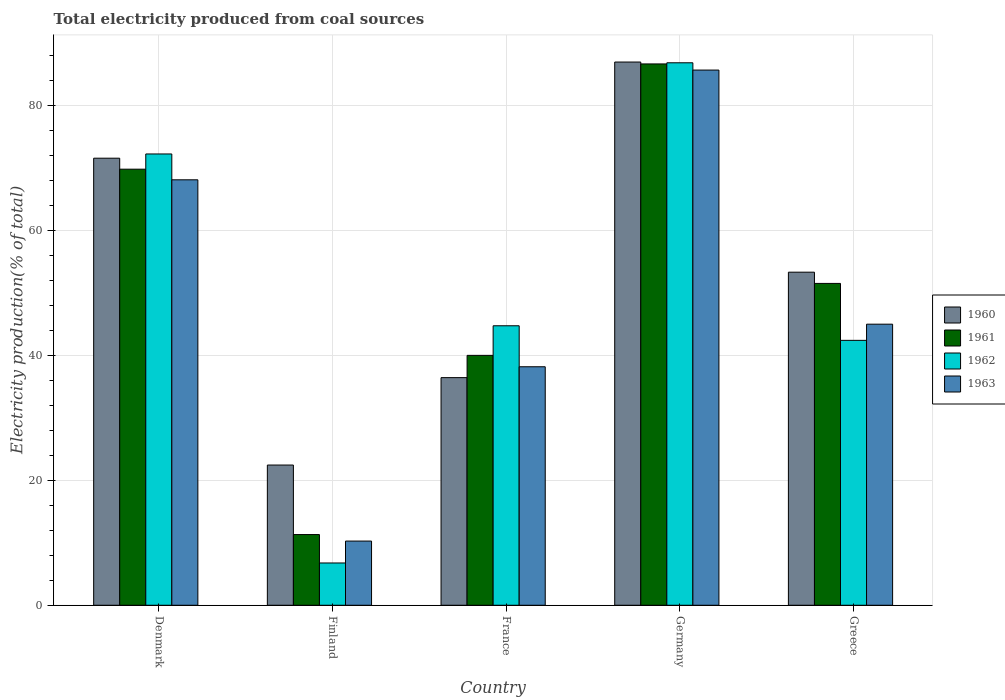How many groups of bars are there?
Offer a terse response. 5. What is the label of the 5th group of bars from the left?
Ensure brevity in your answer.  Greece. What is the total electricity produced in 1963 in Greece?
Offer a very short reply. 45.03. Across all countries, what is the maximum total electricity produced in 1961?
Make the answer very short. 86.73. Across all countries, what is the minimum total electricity produced in 1961?
Your answer should be very brief. 11.33. In which country was the total electricity produced in 1962 maximum?
Provide a short and direct response. Germany. In which country was the total electricity produced in 1962 minimum?
Your answer should be compact. Finland. What is the total total electricity produced in 1961 in the graph?
Make the answer very short. 259.52. What is the difference between the total electricity produced in 1960 in France and that in Germany?
Provide a succinct answer. -50.56. What is the difference between the total electricity produced in 1961 in Greece and the total electricity produced in 1962 in Germany?
Give a very brief answer. -35.35. What is the average total electricity produced in 1962 per country?
Your answer should be compact. 50.64. What is the difference between the total electricity produced of/in 1963 and total electricity produced of/in 1960 in Denmark?
Offer a very short reply. -3.46. What is the ratio of the total electricity produced in 1963 in Denmark to that in Greece?
Make the answer very short. 1.51. Is the total electricity produced in 1963 in Denmark less than that in Finland?
Your answer should be very brief. No. Is the difference between the total electricity produced in 1963 in Finland and Germany greater than the difference between the total electricity produced in 1960 in Finland and Germany?
Offer a very short reply. No. What is the difference between the highest and the second highest total electricity produced in 1962?
Offer a very short reply. 27.52. What is the difference between the highest and the lowest total electricity produced in 1961?
Ensure brevity in your answer.  75.4. In how many countries, is the total electricity produced in 1962 greater than the average total electricity produced in 1962 taken over all countries?
Ensure brevity in your answer.  2. Is it the case that in every country, the sum of the total electricity produced in 1962 and total electricity produced in 1963 is greater than the sum of total electricity produced in 1960 and total electricity produced in 1961?
Offer a terse response. No. What does the 3rd bar from the right in France represents?
Your answer should be very brief. 1961. Is it the case that in every country, the sum of the total electricity produced in 1960 and total electricity produced in 1962 is greater than the total electricity produced in 1963?
Ensure brevity in your answer.  Yes. What is the difference between two consecutive major ticks on the Y-axis?
Offer a very short reply. 20. Are the values on the major ticks of Y-axis written in scientific E-notation?
Your answer should be very brief. No. Does the graph contain grids?
Provide a succinct answer. Yes. Where does the legend appear in the graph?
Provide a short and direct response. Center right. How are the legend labels stacked?
Offer a very short reply. Vertical. What is the title of the graph?
Provide a succinct answer. Total electricity produced from coal sources. Does "1977" appear as one of the legend labels in the graph?
Make the answer very short. No. What is the Electricity production(% of total) of 1960 in Denmark?
Your answer should be compact. 71.62. What is the Electricity production(% of total) in 1961 in Denmark?
Keep it short and to the point. 69.86. What is the Electricity production(% of total) in 1962 in Denmark?
Ensure brevity in your answer.  72.3. What is the Electricity production(% of total) in 1963 in Denmark?
Make the answer very short. 68.16. What is the Electricity production(% of total) in 1960 in Finland?
Provide a short and direct response. 22.46. What is the Electricity production(% of total) of 1961 in Finland?
Your response must be concise. 11.33. What is the Electricity production(% of total) of 1962 in Finland?
Your answer should be very brief. 6.78. What is the Electricity production(% of total) in 1963 in Finland?
Offer a terse response. 10.28. What is the Electricity production(% of total) of 1960 in France?
Offer a terse response. 36.47. What is the Electricity production(% of total) in 1961 in France?
Give a very brief answer. 40.03. What is the Electricity production(% of total) in 1962 in France?
Keep it short and to the point. 44.78. What is the Electricity production(% of total) of 1963 in France?
Make the answer very short. 38.21. What is the Electricity production(% of total) of 1960 in Germany?
Offer a very short reply. 87.03. What is the Electricity production(% of total) in 1961 in Germany?
Your response must be concise. 86.73. What is the Electricity production(% of total) of 1962 in Germany?
Make the answer very short. 86.91. What is the Electricity production(% of total) of 1963 in Germany?
Provide a short and direct response. 85.74. What is the Electricity production(% of total) of 1960 in Greece?
Your answer should be compact. 53.36. What is the Electricity production(% of total) of 1961 in Greece?
Ensure brevity in your answer.  51.56. What is the Electricity production(% of total) in 1962 in Greece?
Provide a succinct answer. 42.44. What is the Electricity production(% of total) of 1963 in Greece?
Provide a short and direct response. 45.03. Across all countries, what is the maximum Electricity production(% of total) in 1960?
Your answer should be compact. 87.03. Across all countries, what is the maximum Electricity production(% of total) in 1961?
Ensure brevity in your answer.  86.73. Across all countries, what is the maximum Electricity production(% of total) of 1962?
Your response must be concise. 86.91. Across all countries, what is the maximum Electricity production(% of total) of 1963?
Your answer should be very brief. 85.74. Across all countries, what is the minimum Electricity production(% of total) in 1960?
Keep it short and to the point. 22.46. Across all countries, what is the minimum Electricity production(% of total) of 1961?
Keep it short and to the point. 11.33. Across all countries, what is the minimum Electricity production(% of total) in 1962?
Keep it short and to the point. 6.78. Across all countries, what is the minimum Electricity production(% of total) in 1963?
Give a very brief answer. 10.28. What is the total Electricity production(% of total) in 1960 in the graph?
Provide a succinct answer. 270.95. What is the total Electricity production(% of total) of 1961 in the graph?
Your response must be concise. 259.52. What is the total Electricity production(% of total) of 1962 in the graph?
Provide a short and direct response. 253.2. What is the total Electricity production(% of total) in 1963 in the graph?
Your answer should be compact. 247.43. What is the difference between the Electricity production(% of total) of 1960 in Denmark and that in Finland?
Make the answer very short. 49.16. What is the difference between the Electricity production(% of total) of 1961 in Denmark and that in Finland?
Offer a very short reply. 58.54. What is the difference between the Electricity production(% of total) of 1962 in Denmark and that in Finland?
Make the answer very short. 65.53. What is the difference between the Electricity production(% of total) in 1963 in Denmark and that in Finland?
Ensure brevity in your answer.  57.88. What is the difference between the Electricity production(% of total) of 1960 in Denmark and that in France?
Ensure brevity in your answer.  35.16. What is the difference between the Electricity production(% of total) of 1961 in Denmark and that in France?
Keep it short and to the point. 29.83. What is the difference between the Electricity production(% of total) of 1962 in Denmark and that in France?
Ensure brevity in your answer.  27.52. What is the difference between the Electricity production(% of total) of 1963 in Denmark and that in France?
Make the answer very short. 29.95. What is the difference between the Electricity production(% of total) of 1960 in Denmark and that in Germany?
Your answer should be very brief. -15.4. What is the difference between the Electricity production(% of total) in 1961 in Denmark and that in Germany?
Give a very brief answer. -16.86. What is the difference between the Electricity production(% of total) of 1962 in Denmark and that in Germany?
Your response must be concise. -14.61. What is the difference between the Electricity production(% of total) of 1963 in Denmark and that in Germany?
Offer a very short reply. -17.58. What is the difference between the Electricity production(% of total) in 1960 in Denmark and that in Greece?
Make the answer very short. 18.26. What is the difference between the Electricity production(% of total) in 1961 in Denmark and that in Greece?
Provide a succinct answer. 18.3. What is the difference between the Electricity production(% of total) in 1962 in Denmark and that in Greece?
Offer a very short reply. 29.86. What is the difference between the Electricity production(% of total) of 1963 in Denmark and that in Greece?
Your answer should be compact. 23.13. What is the difference between the Electricity production(% of total) of 1960 in Finland and that in France?
Your answer should be compact. -14.01. What is the difference between the Electricity production(% of total) in 1961 in Finland and that in France?
Give a very brief answer. -28.71. What is the difference between the Electricity production(% of total) in 1962 in Finland and that in France?
Your answer should be compact. -38. What is the difference between the Electricity production(% of total) in 1963 in Finland and that in France?
Your answer should be compact. -27.93. What is the difference between the Electricity production(% of total) in 1960 in Finland and that in Germany?
Offer a very short reply. -64.57. What is the difference between the Electricity production(% of total) of 1961 in Finland and that in Germany?
Provide a succinct answer. -75.4. What is the difference between the Electricity production(% of total) in 1962 in Finland and that in Germany?
Provide a short and direct response. -80.13. What is the difference between the Electricity production(% of total) of 1963 in Finland and that in Germany?
Provide a short and direct response. -75.46. What is the difference between the Electricity production(% of total) in 1960 in Finland and that in Greece?
Provide a short and direct response. -30.9. What is the difference between the Electricity production(% of total) in 1961 in Finland and that in Greece?
Provide a short and direct response. -40.24. What is the difference between the Electricity production(% of total) of 1962 in Finland and that in Greece?
Your answer should be compact. -35.66. What is the difference between the Electricity production(% of total) of 1963 in Finland and that in Greece?
Your answer should be very brief. -34.75. What is the difference between the Electricity production(% of total) in 1960 in France and that in Germany?
Offer a very short reply. -50.56. What is the difference between the Electricity production(% of total) of 1961 in France and that in Germany?
Keep it short and to the point. -46.69. What is the difference between the Electricity production(% of total) in 1962 in France and that in Germany?
Your response must be concise. -42.13. What is the difference between the Electricity production(% of total) of 1963 in France and that in Germany?
Provide a short and direct response. -47.53. What is the difference between the Electricity production(% of total) of 1960 in France and that in Greece?
Your response must be concise. -16.89. What is the difference between the Electricity production(% of total) in 1961 in France and that in Greece?
Provide a short and direct response. -11.53. What is the difference between the Electricity production(% of total) of 1962 in France and that in Greece?
Offer a very short reply. 2.34. What is the difference between the Electricity production(% of total) of 1963 in France and that in Greece?
Give a very brief answer. -6.82. What is the difference between the Electricity production(% of total) of 1960 in Germany and that in Greece?
Your answer should be very brief. 33.67. What is the difference between the Electricity production(% of total) of 1961 in Germany and that in Greece?
Ensure brevity in your answer.  35.16. What is the difference between the Electricity production(% of total) in 1962 in Germany and that in Greece?
Your answer should be compact. 44.47. What is the difference between the Electricity production(% of total) in 1963 in Germany and that in Greece?
Your answer should be compact. 40.71. What is the difference between the Electricity production(% of total) in 1960 in Denmark and the Electricity production(% of total) in 1961 in Finland?
Offer a very short reply. 60.3. What is the difference between the Electricity production(% of total) of 1960 in Denmark and the Electricity production(% of total) of 1962 in Finland?
Keep it short and to the point. 64.85. What is the difference between the Electricity production(% of total) of 1960 in Denmark and the Electricity production(% of total) of 1963 in Finland?
Provide a short and direct response. 61.34. What is the difference between the Electricity production(% of total) in 1961 in Denmark and the Electricity production(% of total) in 1962 in Finland?
Make the answer very short. 63.09. What is the difference between the Electricity production(% of total) of 1961 in Denmark and the Electricity production(% of total) of 1963 in Finland?
Your answer should be very brief. 59.58. What is the difference between the Electricity production(% of total) of 1962 in Denmark and the Electricity production(% of total) of 1963 in Finland?
Give a very brief answer. 62.02. What is the difference between the Electricity production(% of total) in 1960 in Denmark and the Electricity production(% of total) in 1961 in France?
Keep it short and to the point. 31.59. What is the difference between the Electricity production(% of total) in 1960 in Denmark and the Electricity production(% of total) in 1962 in France?
Keep it short and to the point. 26.85. What is the difference between the Electricity production(% of total) in 1960 in Denmark and the Electricity production(% of total) in 1963 in France?
Offer a very short reply. 33.41. What is the difference between the Electricity production(% of total) of 1961 in Denmark and the Electricity production(% of total) of 1962 in France?
Offer a terse response. 25.09. What is the difference between the Electricity production(% of total) in 1961 in Denmark and the Electricity production(% of total) in 1963 in France?
Ensure brevity in your answer.  31.65. What is the difference between the Electricity production(% of total) of 1962 in Denmark and the Electricity production(% of total) of 1963 in France?
Offer a terse response. 34.09. What is the difference between the Electricity production(% of total) in 1960 in Denmark and the Electricity production(% of total) in 1961 in Germany?
Ensure brevity in your answer.  -15.1. What is the difference between the Electricity production(% of total) of 1960 in Denmark and the Electricity production(% of total) of 1962 in Germany?
Your response must be concise. -15.28. What is the difference between the Electricity production(% of total) of 1960 in Denmark and the Electricity production(% of total) of 1963 in Germany?
Make the answer very short. -14.12. What is the difference between the Electricity production(% of total) in 1961 in Denmark and the Electricity production(% of total) in 1962 in Germany?
Offer a very short reply. -17.04. What is the difference between the Electricity production(% of total) in 1961 in Denmark and the Electricity production(% of total) in 1963 in Germany?
Your answer should be compact. -15.88. What is the difference between the Electricity production(% of total) in 1962 in Denmark and the Electricity production(% of total) in 1963 in Germany?
Your response must be concise. -13.44. What is the difference between the Electricity production(% of total) in 1960 in Denmark and the Electricity production(% of total) in 1961 in Greece?
Provide a short and direct response. 20.06. What is the difference between the Electricity production(% of total) of 1960 in Denmark and the Electricity production(% of total) of 1962 in Greece?
Provide a short and direct response. 29.18. What is the difference between the Electricity production(% of total) of 1960 in Denmark and the Electricity production(% of total) of 1963 in Greece?
Provide a succinct answer. 26.59. What is the difference between the Electricity production(% of total) in 1961 in Denmark and the Electricity production(% of total) in 1962 in Greece?
Give a very brief answer. 27.42. What is the difference between the Electricity production(% of total) in 1961 in Denmark and the Electricity production(% of total) in 1963 in Greece?
Your response must be concise. 24.83. What is the difference between the Electricity production(% of total) in 1962 in Denmark and the Electricity production(% of total) in 1963 in Greece?
Make the answer very short. 27.27. What is the difference between the Electricity production(% of total) in 1960 in Finland and the Electricity production(% of total) in 1961 in France?
Your answer should be compact. -17.57. What is the difference between the Electricity production(% of total) of 1960 in Finland and the Electricity production(% of total) of 1962 in France?
Make the answer very short. -22.31. What is the difference between the Electricity production(% of total) of 1960 in Finland and the Electricity production(% of total) of 1963 in France?
Provide a short and direct response. -15.75. What is the difference between the Electricity production(% of total) in 1961 in Finland and the Electricity production(% of total) in 1962 in France?
Ensure brevity in your answer.  -33.45. What is the difference between the Electricity production(% of total) in 1961 in Finland and the Electricity production(% of total) in 1963 in France?
Offer a terse response. -26.88. What is the difference between the Electricity production(% of total) in 1962 in Finland and the Electricity production(% of total) in 1963 in France?
Your answer should be very brief. -31.44. What is the difference between the Electricity production(% of total) of 1960 in Finland and the Electricity production(% of total) of 1961 in Germany?
Keep it short and to the point. -64.26. What is the difference between the Electricity production(% of total) in 1960 in Finland and the Electricity production(% of total) in 1962 in Germany?
Offer a terse response. -64.45. What is the difference between the Electricity production(% of total) in 1960 in Finland and the Electricity production(% of total) in 1963 in Germany?
Offer a very short reply. -63.28. What is the difference between the Electricity production(% of total) of 1961 in Finland and the Electricity production(% of total) of 1962 in Germany?
Your response must be concise. -75.58. What is the difference between the Electricity production(% of total) of 1961 in Finland and the Electricity production(% of total) of 1963 in Germany?
Offer a very short reply. -74.41. What is the difference between the Electricity production(% of total) in 1962 in Finland and the Electricity production(% of total) in 1963 in Germany?
Offer a terse response. -78.97. What is the difference between the Electricity production(% of total) in 1960 in Finland and the Electricity production(% of total) in 1961 in Greece?
Keep it short and to the point. -29.1. What is the difference between the Electricity production(% of total) in 1960 in Finland and the Electricity production(% of total) in 1962 in Greece?
Provide a succinct answer. -19.98. What is the difference between the Electricity production(% of total) in 1960 in Finland and the Electricity production(% of total) in 1963 in Greece?
Offer a very short reply. -22.57. What is the difference between the Electricity production(% of total) of 1961 in Finland and the Electricity production(% of total) of 1962 in Greece?
Provide a succinct answer. -31.11. What is the difference between the Electricity production(% of total) of 1961 in Finland and the Electricity production(% of total) of 1963 in Greece?
Keep it short and to the point. -33.7. What is the difference between the Electricity production(% of total) in 1962 in Finland and the Electricity production(% of total) in 1963 in Greece?
Ensure brevity in your answer.  -38.26. What is the difference between the Electricity production(% of total) of 1960 in France and the Electricity production(% of total) of 1961 in Germany?
Offer a very short reply. -50.26. What is the difference between the Electricity production(% of total) in 1960 in France and the Electricity production(% of total) in 1962 in Germany?
Offer a terse response. -50.44. What is the difference between the Electricity production(% of total) of 1960 in France and the Electricity production(% of total) of 1963 in Germany?
Provide a short and direct response. -49.27. What is the difference between the Electricity production(% of total) of 1961 in France and the Electricity production(% of total) of 1962 in Germany?
Provide a succinct answer. -46.87. What is the difference between the Electricity production(% of total) in 1961 in France and the Electricity production(% of total) in 1963 in Germany?
Give a very brief answer. -45.71. What is the difference between the Electricity production(% of total) in 1962 in France and the Electricity production(% of total) in 1963 in Germany?
Offer a terse response. -40.97. What is the difference between the Electricity production(% of total) in 1960 in France and the Electricity production(% of total) in 1961 in Greece?
Offer a very short reply. -15.09. What is the difference between the Electricity production(% of total) in 1960 in France and the Electricity production(% of total) in 1962 in Greece?
Provide a succinct answer. -5.97. What is the difference between the Electricity production(% of total) of 1960 in France and the Electricity production(% of total) of 1963 in Greece?
Keep it short and to the point. -8.56. What is the difference between the Electricity production(% of total) in 1961 in France and the Electricity production(% of total) in 1962 in Greece?
Offer a terse response. -2.41. What is the difference between the Electricity production(% of total) in 1961 in France and the Electricity production(% of total) in 1963 in Greece?
Give a very brief answer. -5. What is the difference between the Electricity production(% of total) in 1962 in France and the Electricity production(% of total) in 1963 in Greece?
Make the answer very short. -0.25. What is the difference between the Electricity production(% of total) of 1960 in Germany and the Electricity production(% of total) of 1961 in Greece?
Offer a very short reply. 35.47. What is the difference between the Electricity production(% of total) of 1960 in Germany and the Electricity production(% of total) of 1962 in Greece?
Your answer should be very brief. 44.59. What is the difference between the Electricity production(% of total) in 1960 in Germany and the Electricity production(% of total) in 1963 in Greece?
Ensure brevity in your answer.  42. What is the difference between the Electricity production(% of total) in 1961 in Germany and the Electricity production(% of total) in 1962 in Greece?
Offer a terse response. 44.29. What is the difference between the Electricity production(% of total) of 1961 in Germany and the Electricity production(% of total) of 1963 in Greece?
Offer a very short reply. 41.69. What is the difference between the Electricity production(% of total) of 1962 in Germany and the Electricity production(% of total) of 1963 in Greece?
Offer a terse response. 41.88. What is the average Electricity production(% of total) in 1960 per country?
Your answer should be compact. 54.19. What is the average Electricity production(% of total) in 1961 per country?
Provide a succinct answer. 51.9. What is the average Electricity production(% of total) in 1962 per country?
Your response must be concise. 50.64. What is the average Electricity production(% of total) of 1963 per country?
Your response must be concise. 49.49. What is the difference between the Electricity production(% of total) of 1960 and Electricity production(% of total) of 1961 in Denmark?
Your response must be concise. 1.76. What is the difference between the Electricity production(% of total) of 1960 and Electricity production(% of total) of 1962 in Denmark?
Your response must be concise. -0.68. What is the difference between the Electricity production(% of total) of 1960 and Electricity production(% of total) of 1963 in Denmark?
Your response must be concise. 3.46. What is the difference between the Electricity production(% of total) of 1961 and Electricity production(% of total) of 1962 in Denmark?
Offer a terse response. -2.44. What is the difference between the Electricity production(% of total) of 1961 and Electricity production(% of total) of 1963 in Denmark?
Give a very brief answer. 1.7. What is the difference between the Electricity production(% of total) of 1962 and Electricity production(% of total) of 1963 in Denmark?
Offer a very short reply. 4.14. What is the difference between the Electricity production(% of total) in 1960 and Electricity production(% of total) in 1961 in Finland?
Your answer should be compact. 11.14. What is the difference between the Electricity production(% of total) of 1960 and Electricity production(% of total) of 1962 in Finland?
Ensure brevity in your answer.  15.69. What is the difference between the Electricity production(% of total) of 1960 and Electricity production(% of total) of 1963 in Finland?
Offer a very short reply. 12.18. What is the difference between the Electricity production(% of total) of 1961 and Electricity production(% of total) of 1962 in Finland?
Offer a terse response. 4.55. What is the difference between the Electricity production(% of total) in 1961 and Electricity production(% of total) in 1963 in Finland?
Offer a terse response. 1.04. What is the difference between the Electricity production(% of total) of 1962 and Electricity production(% of total) of 1963 in Finland?
Provide a succinct answer. -3.51. What is the difference between the Electricity production(% of total) in 1960 and Electricity production(% of total) in 1961 in France?
Provide a succinct answer. -3.57. What is the difference between the Electricity production(% of total) of 1960 and Electricity production(% of total) of 1962 in France?
Keep it short and to the point. -8.31. What is the difference between the Electricity production(% of total) in 1960 and Electricity production(% of total) in 1963 in France?
Your answer should be compact. -1.74. What is the difference between the Electricity production(% of total) in 1961 and Electricity production(% of total) in 1962 in France?
Offer a very short reply. -4.74. What is the difference between the Electricity production(% of total) of 1961 and Electricity production(% of total) of 1963 in France?
Your answer should be compact. 1.82. What is the difference between the Electricity production(% of total) of 1962 and Electricity production(% of total) of 1963 in France?
Your answer should be very brief. 6.57. What is the difference between the Electricity production(% of total) in 1960 and Electricity production(% of total) in 1961 in Germany?
Offer a terse response. 0.3. What is the difference between the Electricity production(% of total) of 1960 and Electricity production(% of total) of 1962 in Germany?
Offer a very short reply. 0.12. What is the difference between the Electricity production(% of total) in 1960 and Electricity production(% of total) in 1963 in Germany?
Offer a very short reply. 1.29. What is the difference between the Electricity production(% of total) in 1961 and Electricity production(% of total) in 1962 in Germany?
Offer a very short reply. -0.18. What is the difference between the Electricity production(% of total) of 1961 and Electricity production(% of total) of 1963 in Germany?
Give a very brief answer. 0.98. What is the difference between the Electricity production(% of total) of 1960 and Electricity production(% of total) of 1961 in Greece?
Your answer should be very brief. 1.8. What is the difference between the Electricity production(% of total) in 1960 and Electricity production(% of total) in 1962 in Greece?
Offer a very short reply. 10.92. What is the difference between the Electricity production(% of total) of 1960 and Electricity production(% of total) of 1963 in Greece?
Give a very brief answer. 8.33. What is the difference between the Electricity production(% of total) in 1961 and Electricity production(% of total) in 1962 in Greece?
Offer a very short reply. 9.12. What is the difference between the Electricity production(% of total) in 1961 and Electricity production(% of total) in 1963 in Greece?
Your answer should be very brief. 6.53. What is the difference between the Electricity production(% of total) of 1962 and Electricity production(% of total) of 1963 in Greece?
Your response must be concise. -2.59. What is the ratio of the Electricity production(% of total) in 1960 in Denmark to that in Finland?
Offer a terse response. 3.19. What is the ratio of the Electricity production(% of total) in 1961 in Denmark to that in Finland?
Your response must be concise. 6.17. What is the ratio of the Electricity production(% of total) in 1962 in Denmark to that in Finland?
Provide a short and direct response. 10.67. What is the ratio of the Electricity production(% of total) of 1963 in Denmark to that in Finland?
Your response must be concise. 6.63. What is the ratio of the Electricity production(% of total) in 1960 in Denmark to that in France?
Give a very brief answer. 1.96. What is the ratio of the Electricity production(% of total) of 1961 in Denmark to that in France?
Keep it short and to the point. 1.75. What is the ratio of the Electricity production(% of total) of 1962 in Denmark to that in France?
Your answer should be very brief. 1.61. What is the ratio of the Electricity production(% of total) of 1963 in Denmark to that in France?
Provide a short and direct response. 1.78. What is the ratio of the Electricity production(% of total) in 1960 in Denmark to that in Germany?
Your answer should be very brief. 0.82. What is the ratio of the Electricity production(% of total) of 1961 in Denmark to that in Germany?
Your answer should be very brief. 0.81. What is the ratio of the Electricity production(% of total) in 1962 in Denmark to that in Germany?
Keep it short and to the point. 0.83. What is the ratio of the Electricity production(% of total) in 1963 in Denmark to that in Germany?
Offer a very short reply. 0.79. What is the ratio of the Electricity production(% of total) of 1960 in Denmark to that in Greece?
Provide a succinct answer. 1.34. What is the ratio of the Electricity production(% of total) in 1961 in Denmark to that in Greece?
Your response must be concise. 1.35. What is the ratio of the Electricity production(% of total) in 1962 in Denmark to that in Greece?
Your answer should be compact. 1.7. What is the ratio of the Electricity production(% of total) of 1963 in Denmark to that in Greece?
Your response must be concise. 1.51. What is the ratio of the Electricity production(% of total) in 1960 in Finland to that in France?
Offer a very short reply. 0.62. What is the ratio of the Electricity production(% of total) in 1961 in Finland to that in France?
Give a very brief answer. 0.28. What is the ratio of the Electricity production(% of total) of 1962 in Finland to that in France?
Offer a very short reply. 0.15. What is the ratio of the Electricity production(% of total) of 1963 in Finland to that in France?
Provide a short and direct response. 0.27. What is the ratio of the Electricity production(% of total) in 1960 in Finland to that in Germany?
Your answer should be very brief. 0.26. What is the ratio of the Electricity production(% of total) in 1961 in Finland to that in Germany?
Your response must be concise. 0.13. What is the ratio of the Electricity production(% of total) in 1962 in Finland to that in Germany?
Ensure brevity in your answer.  0.08. What is the ratio of the Electricity production(% of total) in 1963 in Finland to that in Germany?
Keep it short and to the point. 0.12. What is the ratio of the Electricity production(% of total) of 1960 in Finland to that in Greece?
Ensure brevity in your answer.  0.42. What is the ratio of the Electricity production(% of total) of 1961 in Finland to that in Greece?
Provide a short and direct response. 0.22. What is the ratio of the Electricity production(% of total) in 1962 in Finland to that in Greece?
Provide a succinct answer. 0.16. What is the ratio of the Electricity production(% of total) in 1963 in Finland to that in Greece?
Keep it short and to the point. 0.23. What is the ratio of the Electricity production(% of total) in 1960 in France to that in Germany?
Keep it short and to the point. 0.42. What is the ratio of the Electricity production(% of total) in 1961 in France to that in Germany?
Your response must be concise. 0.46. What is the ratio of the Electricity production(% of total) of 1962 in France to that in Germany?
Ensure brevity in your answer.  0.52. What is the ratio of the Electricity production(% of total) in 1963 in France to that in Germany?
Provide a short and direct response. 0.45. What is the ratio of the Electricity production(% of total) in 1960 in France to that in Greece?
Keep it short and to the point. 0.68. What is the ratio of the Electricity production(% of total) in 1961 in France to that in Greece?
Provide a short and direct response. 0.78. What is the ratio of the Electricity production(% of total) of 1962 in France to that in Greece?
Keep it short and to the point. 1.06. What is the ratio of the Electricity production(% of total) in 1963 in France to that in Greece?
Give a very brief answer. 0.85. What is the ratio of the Electricity production(% of total) in 1960 in Germany to that in Greece?
Provide a succinct answer. 1.63. What is the ratio of the Electricity production(% of total) in 1961 in Germany to that in Greece?
Provide a short and direct response. 1.68. What is the ratio of the Electricity production(% of total) in 1962 in Germany to that in Greece?
Keep it short and to the point. 2.05. What is the ratio of the Electricity production(% of total) of 1963 in Germany to that in Greece?
Offer a very short reply. 1.9. What is the difference between the highest and the second highest Electricity production(% of total) of 1960?
Provide a short and direct response. 15.4. What is the difference between the highest and the second highest Electricity production(% of total) of 1961?
Give a very brief answer. 16.86. What is the difference between the highest and the second highest Electricity production(% of total) of 1962?
Offer a terse response. 14.61. What is the difference between the highest and the second highest Electricity production(% of total) of 1963?
Provide a short and direct response. 17.58. What is the difference between the highest and the lowest Electricity production(% of total) of 1960?
Provide a succinct answer. 64.57. What is the difference between the highest and the lowest Electricity production(% of total) of 1961?
Keep it short and to the point. 75.4. What is the difference between the highest and the lowest Electricity production(% of total) of 1962?
Your answer should be compact. 80.13. What is the difference between the highest and the lowest Electricity production(% of total) in 1963?
Your answer should be compact. 75.46. 